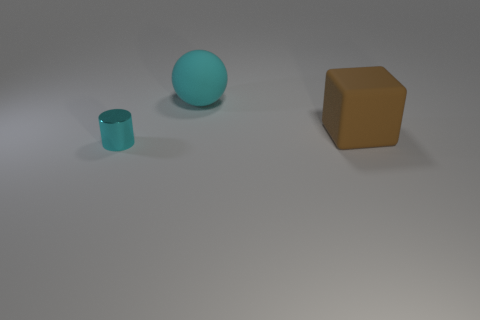What is the material of the other object that is the same color as the tiny thing?
Your response must be concise. Rubber. Is there anything else that has the same shape as the small cyan metallic object?
Make the answer very short. No. What is the cyan object that is right of the small cyan metal object made of?
Ensure brevity in your answer.  Rubber. Are there any other things that have the same size as the cyan ball?
Make the answer very short. Yes. Are there any cyan cylinders left of the small cyan metallic cylinder?
Provide a short and direct response. No. What is the shape of the large cyan matte thing?
Your answer should be very brief. Sphere. What number of things are either objects right of the tiny shiny cylinder or rubber spheres?
Ensure brevity in your answer.  2. How many other things are there of the same color as the small cylinder?
Provide a succinct answer. 1. Is the color of the big ball the same as the object in front of the large brown object?
Offer a very short reply. Yes. Is the small cyan object made of the same material as the big object in front of the cyan rubber ball?
Your answer should be compact. No. 